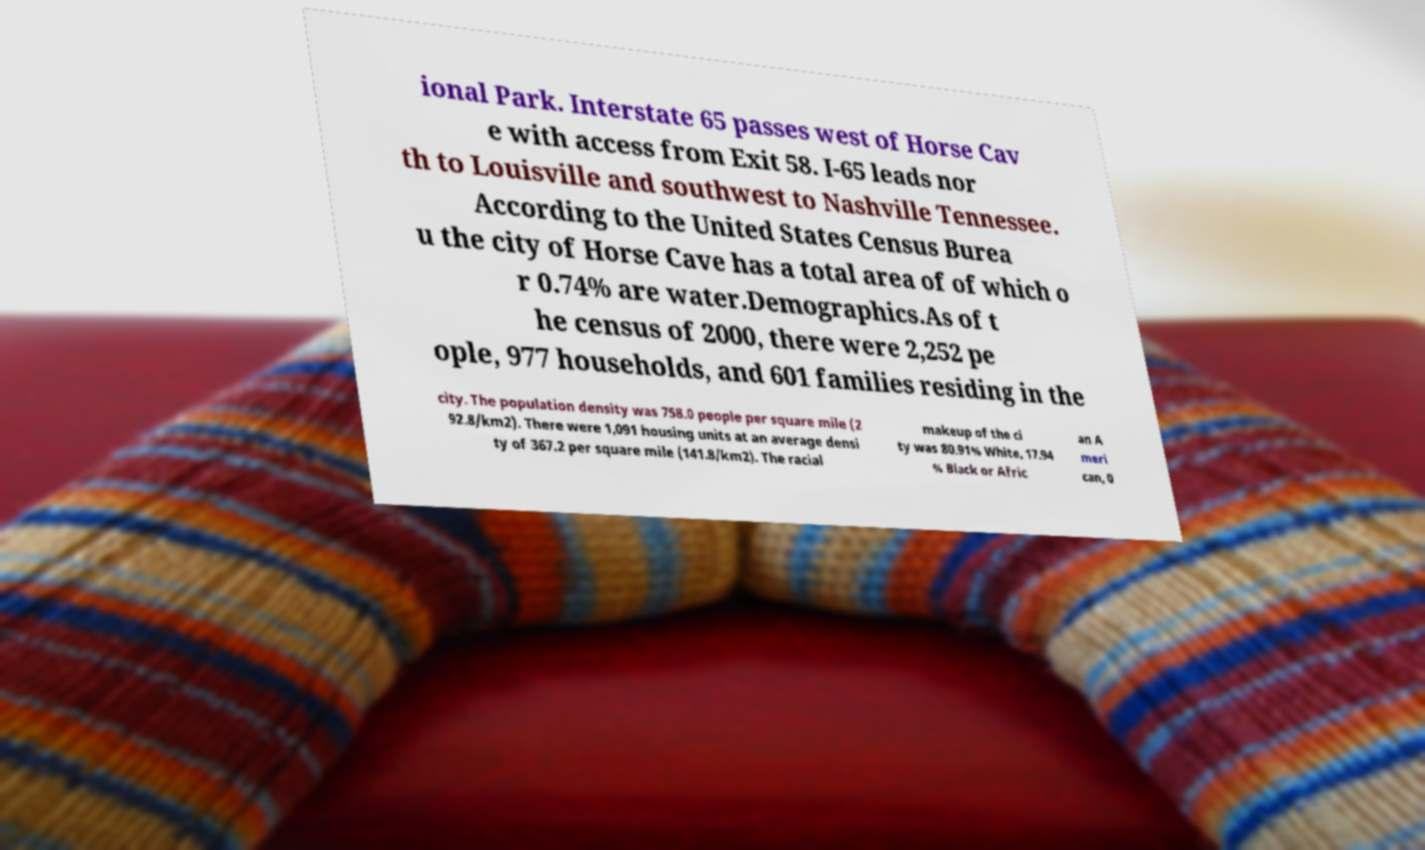Could you assist in decoding the text presented in this image and type it out clearly? ional Park. Interstate 65 passes west of Horse Cav e with access from Exit 58. I-65 leads nor th to Louisville and southwest to Nashville Tennessee. According to the United States Census Burea u the city of Horse Cave has a total area of of which o r 0.74% are water.Demographics.As of t he census of 2000, there were 2,252 pe ople, 977 households, and 601 families residing in the city. The population density was 758.0 people per square mile (2 92.8/km2). There were 1,091 housing units at an average densi ty of 367.2 per square mile (141.8/km2). The racial makeup of the ci ty was 80.91% White, 17.94 % Black or Afric an A meri can, 0 